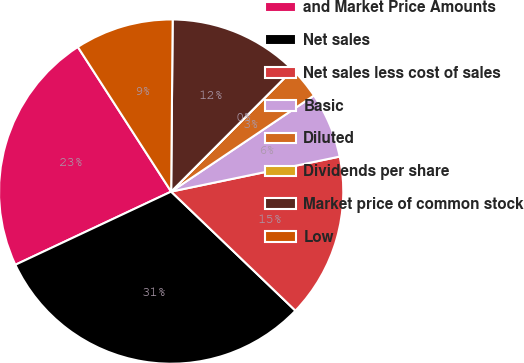Convert chart to OTSL. <chart><loc_0><loc_0><loc_500><loc_500><pie_chart><fcel>and Market Price Amounts<fcel>Net sales<fcel>Net sales less cost of sales<fcel>Basic<fcel>Diluted<fcel>Dividends per share<fcel>Market price of common stock<fcel>Low<nl><fcel>22.87%<fcel>30.85%<fcel>15.42%<fcel>6.17%<fcel>3.09%<fcel>0.0%<fcel>12.34%<fcel>9.26%<nl></chart> 